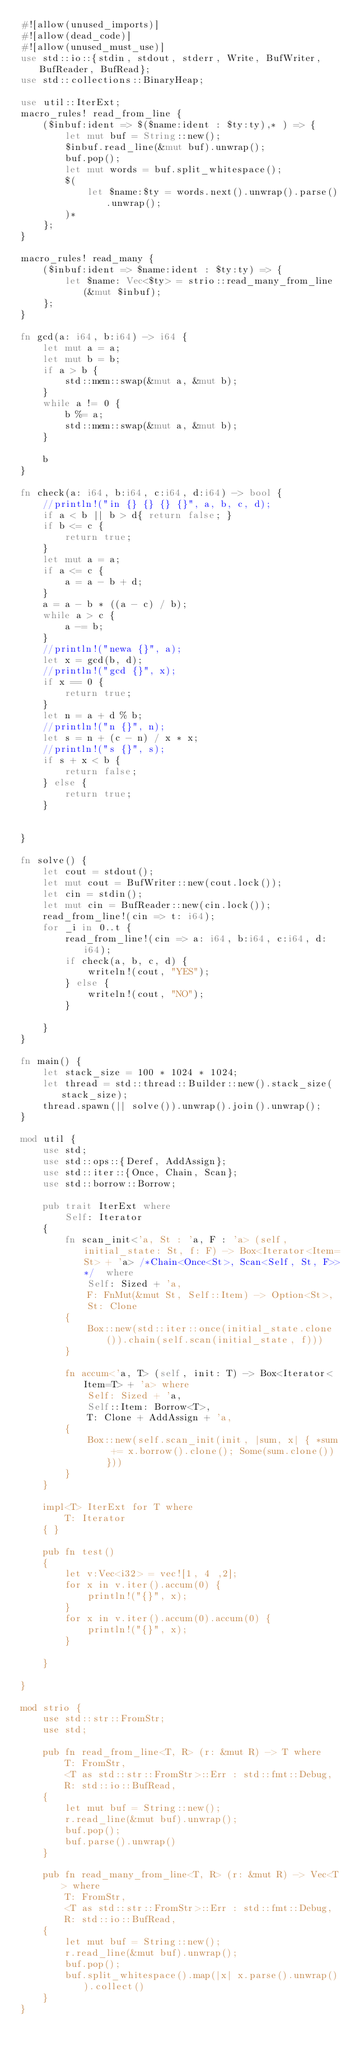Convert code to text. <code><loc_0><loc_0><loc_500><loc_500><_Rust_>#![allow(unused_imports)]
#![allow(dead_code)]
#![allow(unused_must_use)]
use std::io::{stdin, stdout, stderr, Write, BufWriter, BufReader, BufRead};
use std::collections::BinaryHeap;

use util::IterExt;
macro_rules! read_from_line {
    ($inbuf:ident => $($name:ident : $ty:ty),* ) => {
        let mut buf = String::new();
        $inbuf.read_line(&mut buf).unwrap();
        buf.pop();
        let mut words = buf.split_whitespace();
        $(
            let $name:$ty = words.next().unwrap().parse().unwrap();
        )*
    };
}

macro_rules! read_many {
    ($inbuf:ident => $name:ident : $ty:ty) => {
        let $name: Vec<$ty> = strio::read_many_from_line(&mut $inbuf);
    };
}

fn gcd(a: i64, b:i64) -> i64 {
    let mut a = a;
    let mut b = b;
    if a > b {
        std::mem::swap(&mut a, &mut b);
    }
    while a != 0 {
        b %= a;
        std::mem::swap(&mut a, &mut b);
    }

    b
}

fn check(a: i64, b:i64, c:i64, d:i64) -> bool {
    //println!("in {} {} {} {}", a, b, c, d);
    if a < b || b > d{ return false; }
    if b <= c {
        return true;
    }
    let mut a = a;
    if a <= c {
        a = a - b + d;
    }
    a = a - b * ((a - c) / b);
    while a > c {
        a -= b;
    }
    //println!("newa {}", a);
    let x = gcd(b, d);
    //println!("gcd {}", x);
    if x == 0 {
        return true;
    }
    let n = a + d % b;
    //println!("n {}", n);
    let s = n + (c - n) / x * x;
    //println!("s {}", s);
    if s + x < b {
        return false;
    } else {
        return true;
    }


}

fn solve() {
    let cout = stdout();
    let mut cout = BufWriter::new(cout.lock());
    let cin = stdin();
    let mut cin = BufReader::new(cin.lock());
    read_from_line!(cin => t: i64);
    for _i in 0..t {
        read_from_line!(cin => a: i64, b:i64, c:i64, d:i64);
        if check(a, b, c, d) {
            writeln!(cout, "YES");
        } else {
            writeln!(cout, "NO");
        }

    }
}

fn main() {
    let stack_size = 100 * 1024 * 1024;
    let thread = std::thread::Builder::new().stack_size(stack_size);
    thread.spawn(|| solve()).unwrap().join().unwrap();
}

mod util {
    use std;
    use std::ops::{Deref, AddAssign};
    use std::iter::{Once, Chain, Scan};
    use std::borrow::Borrow;

    pub trait IterExt where
        Self: Iterator
    {
        fn scan_init<'a, St : 'a, F : 'a> (self, initial_state: St, f: F) -> Box<Iterator<Item=St> + 'a> /*Chain<Once<St>, Scan<Self, St, F>>*/  where
            Self: Sized + 'a,
            F: FnMut(&mut St, Self::Item) -> Option<St>,
            St: Clone
        {
            Box::new(std::iter::once(initial_state.clone()).chain(self.scan(initial_state, f)))
        }

        fn accum<'a, T> (self, init: T) -> Box<Iterator<Item=T> + 'a> where
            Self: Sized + 'a,
            Self::Item: Borrow<T>,
            T: Clone + AddAssign + 'a,
        {
            Box::new(self.scan_init(init, |sum, x| { *sum += x.borrow().clone(); Some(sum.clone()) }))
        }
    }

    impl<T> IterExt for T where
        T: Iterator
    { }

    pub fn test()
    {
        let v:Vec<i32> = vec![1, 4 ,2];
        for x in v.iter().accum(0) {
            println!("{}", x);
        }
        for x in v.iter().accum(0).accum(0) {
            println!("{}", x);
        }

    }

}

mod strio {
    use std::str::FromStr;
    use std;

    pub fn read_from_line<T, R> (r: &mut R) -> T where
        T: FromStr,
        <T as std::str::FromStr>::Err : std::fmt::Debug,
        R: std::io::BufRead,
    {
        let mut buf = String::new();
        r.read_line(&mut buf).unwrap();
        buf.pop();
        buf.parse().unwrap()
    }

    pub fn read_many_from_line<T, R> (r: &mut R) -> Vec<T> where
        T: FromStr,
        <T as std::str::FromStr>::Err : std::fmt::Debug,
        R: std::io::BufRead,
    {
        let mut buf = String::new();
        r.read_line(&mut buf).unwrap();
        buf.pop();
        buf.split_whitespace().map(|x| x.parse().unwrap()).collect()
    }
}
</code> 